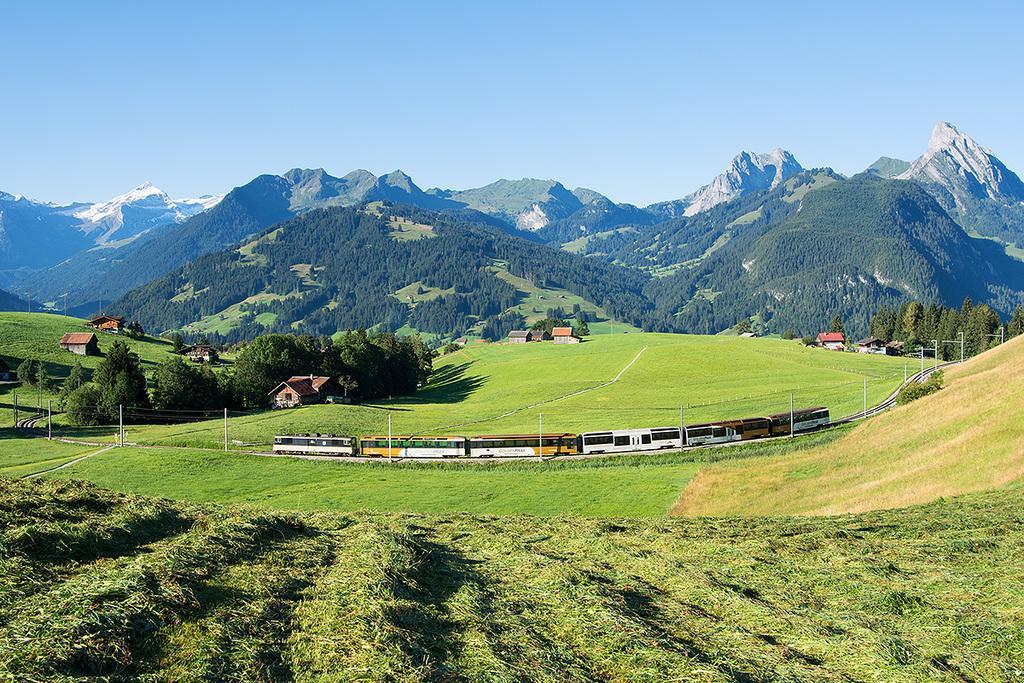Could you give a brief overview of what you see in this image? In this image we can see a train on the track, there are some houses, plants, trees, poles, mountains and grass, in the background we can see the sky. 